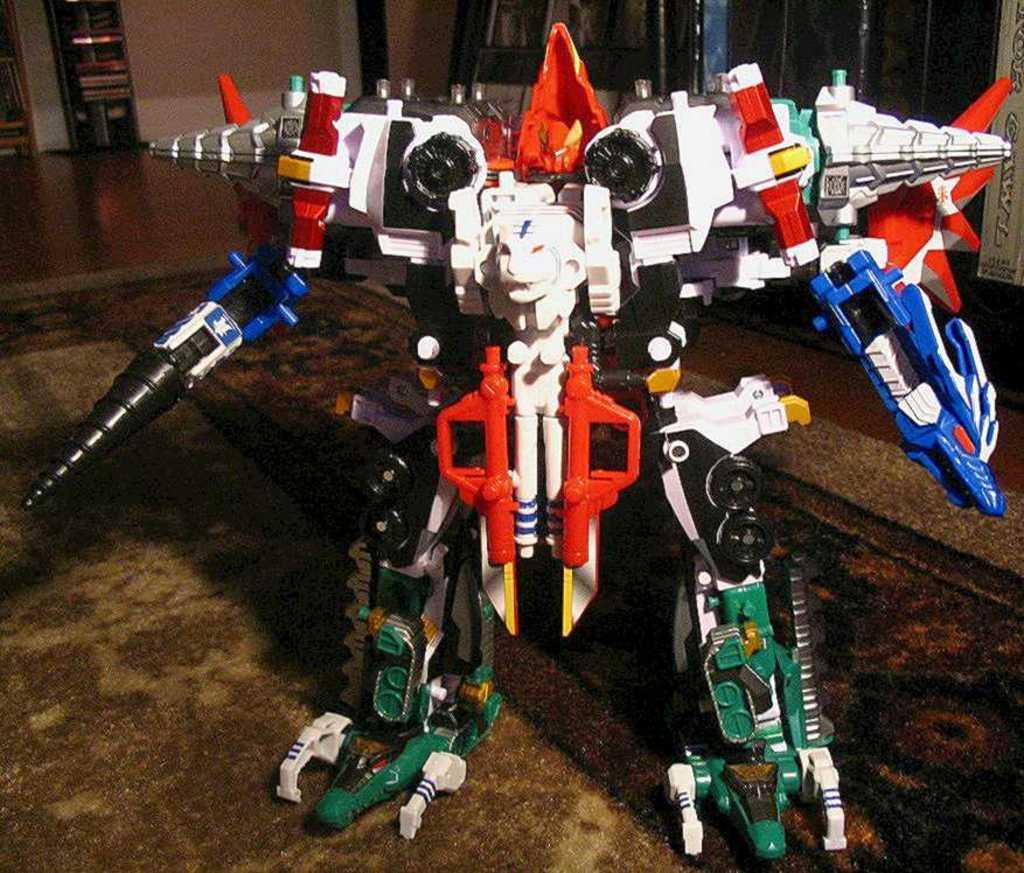Please provide a concise description of this image. This image is taken indoors. At the bottom of the image there is a floor. In the middle of the image there is a toy robot. In the background there are a few walls. 